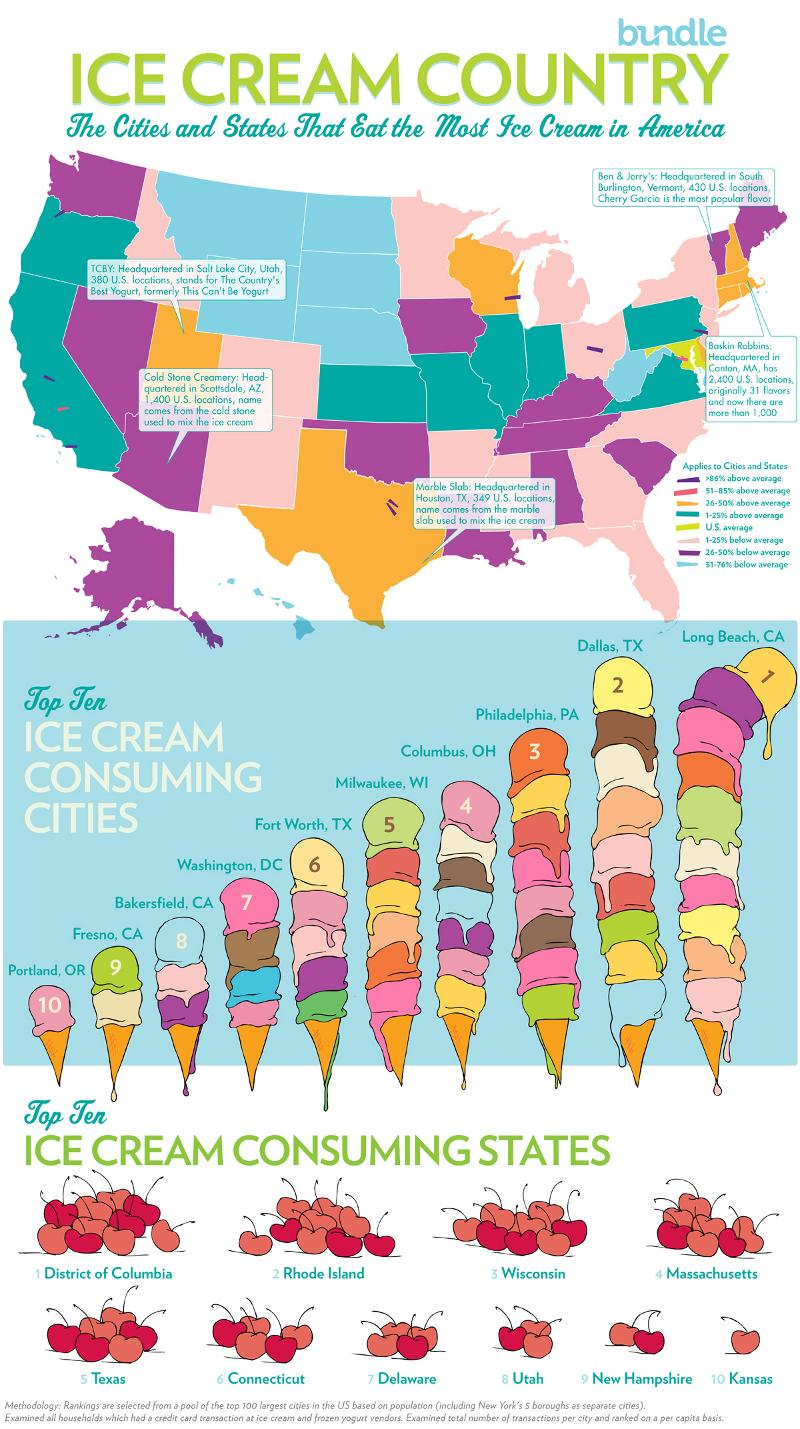Mention a couple of crucial points in this snapshot. Portland, Oregon is the city that consumes ice cream the least. Milwaukee, Wisconsin is ranked fifth in terms of ice cream consumption. The state of District of Columbia consumes the most ice cream. 